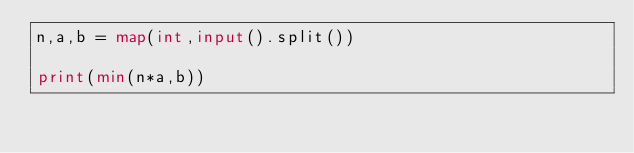<code> <loc_0><loc_0><loc_500><loc_500><_Python_>n,a,b = map(int,input().split())

print(min(n*a,b))</code> 